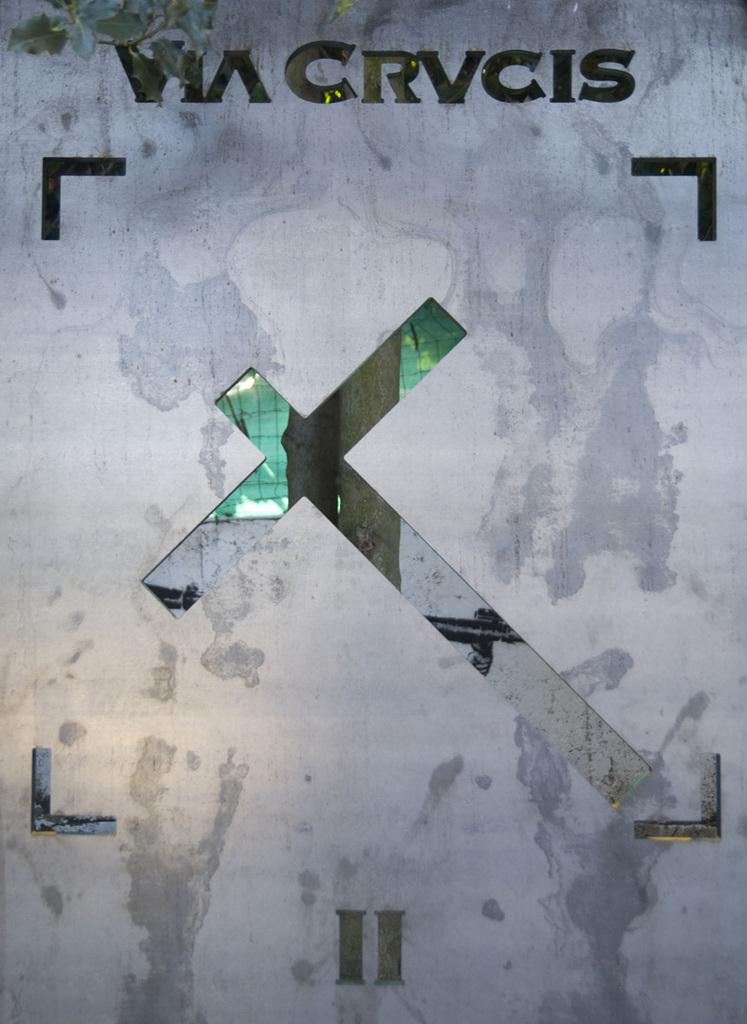What are the roman numerals at the bottom of this?
Ensure brevity in your answer.  Ii. What does the top of this sign say?
Give a very brief answer. Via crvcis. 